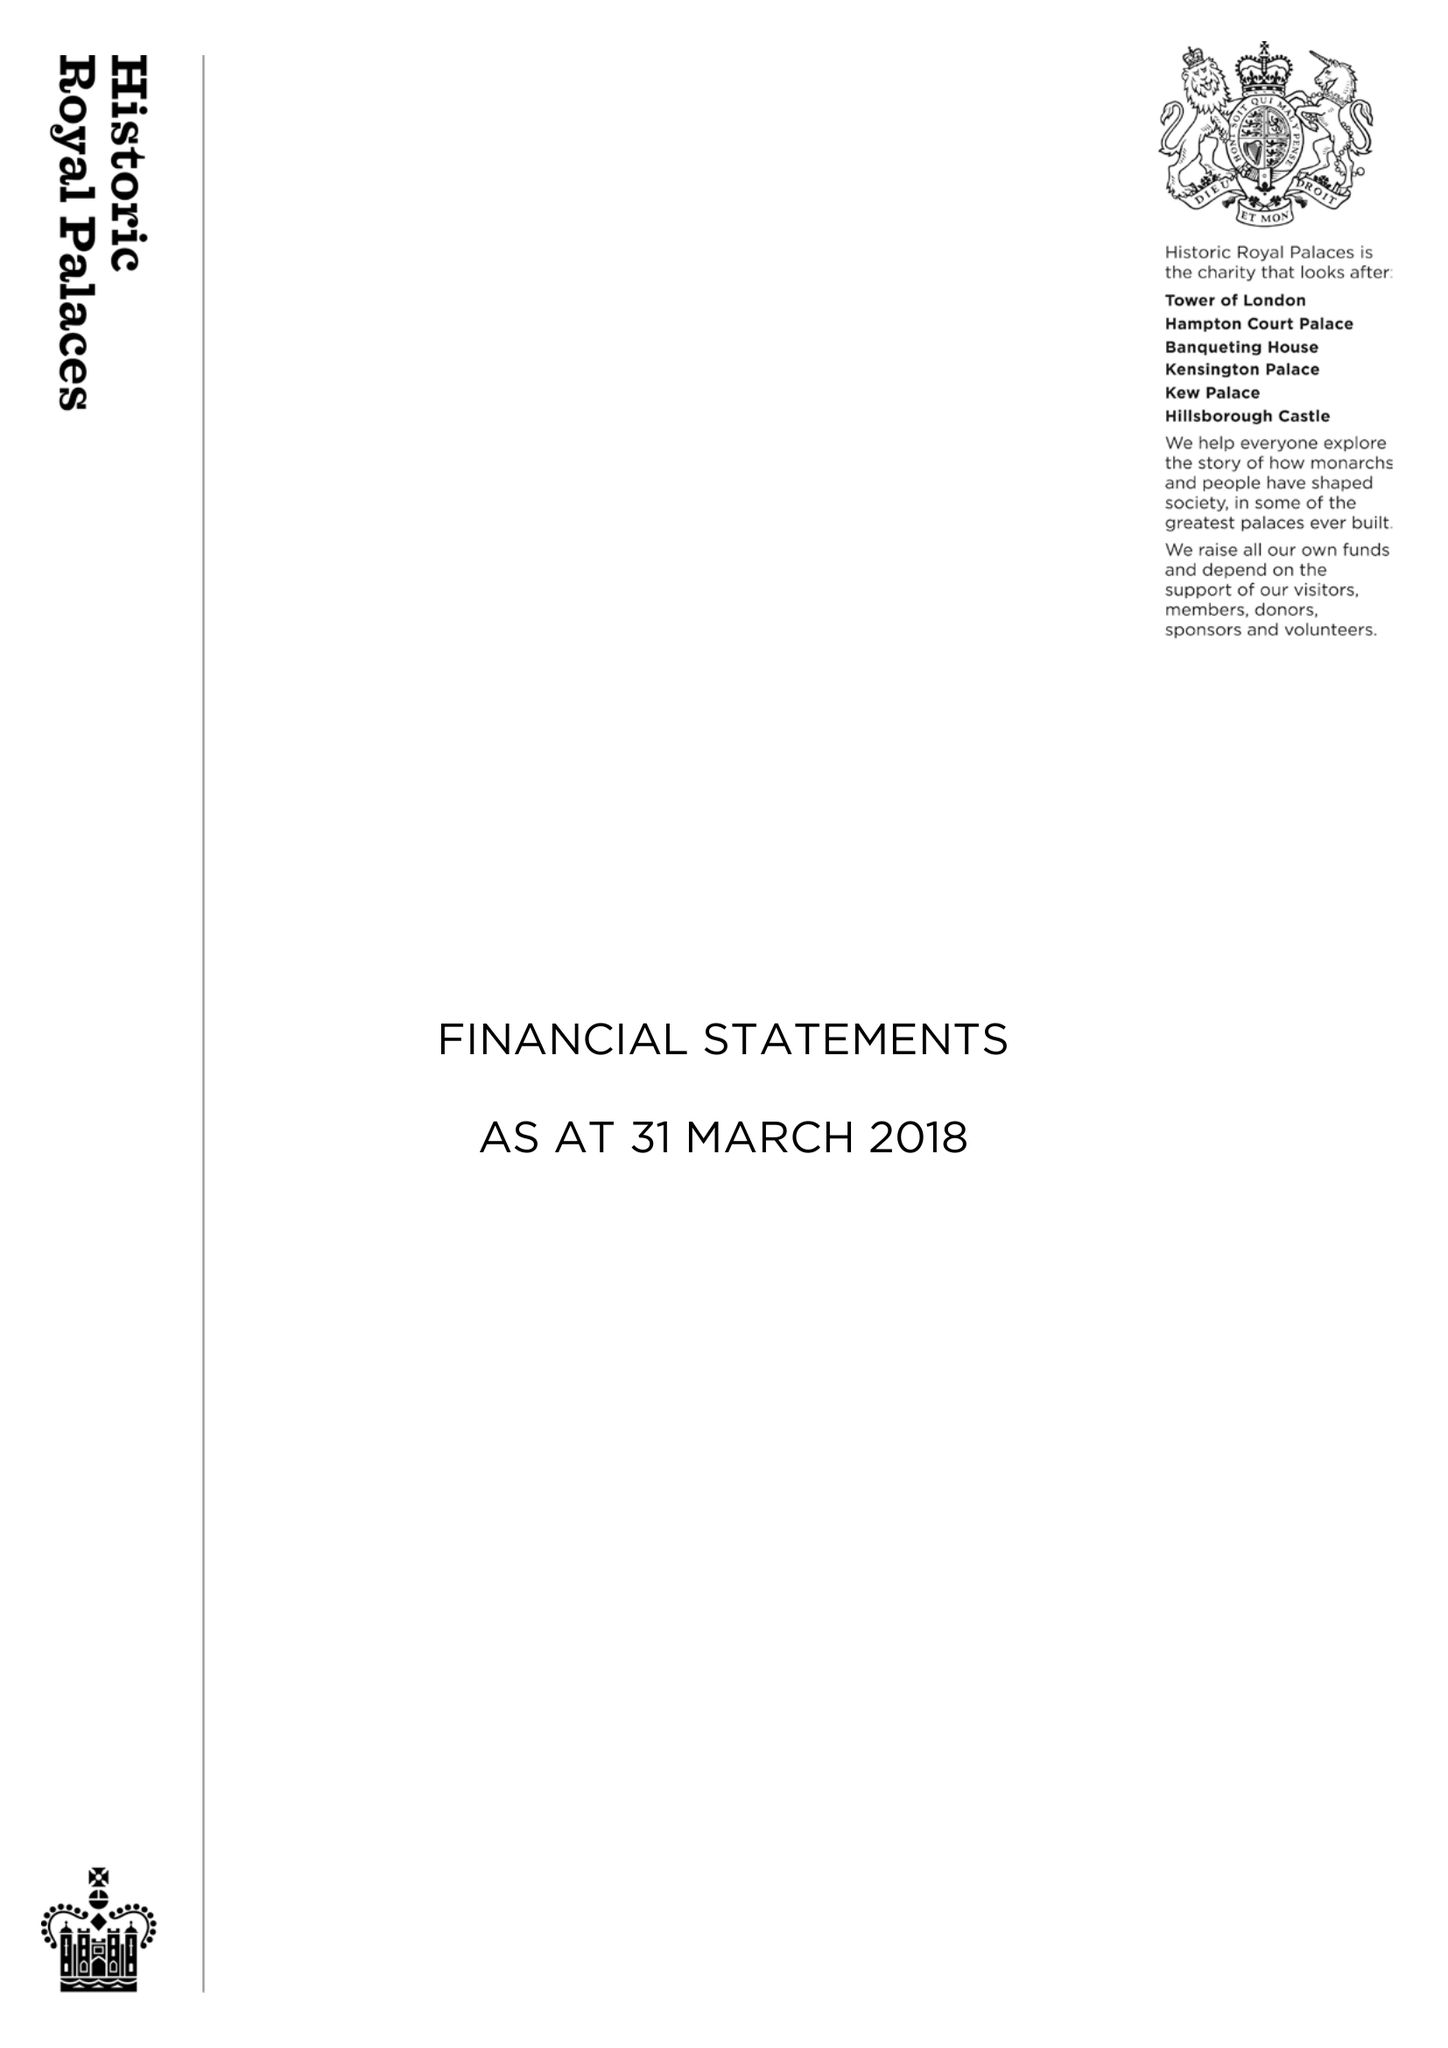What is the value for the report_date?
Answer the question using a single word or phrase. 2018-03-31 